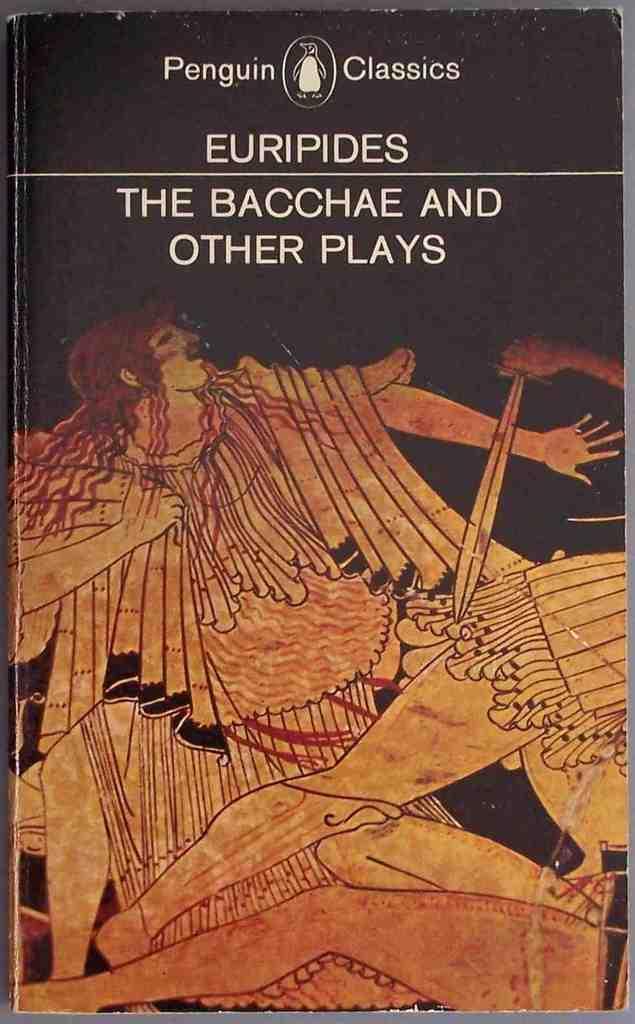Could you give a brief overview of what you see in this image? In this image there is a book having some pictures and some text on top of it. There is painting of humans on it. Top of it there is some text on the book. 